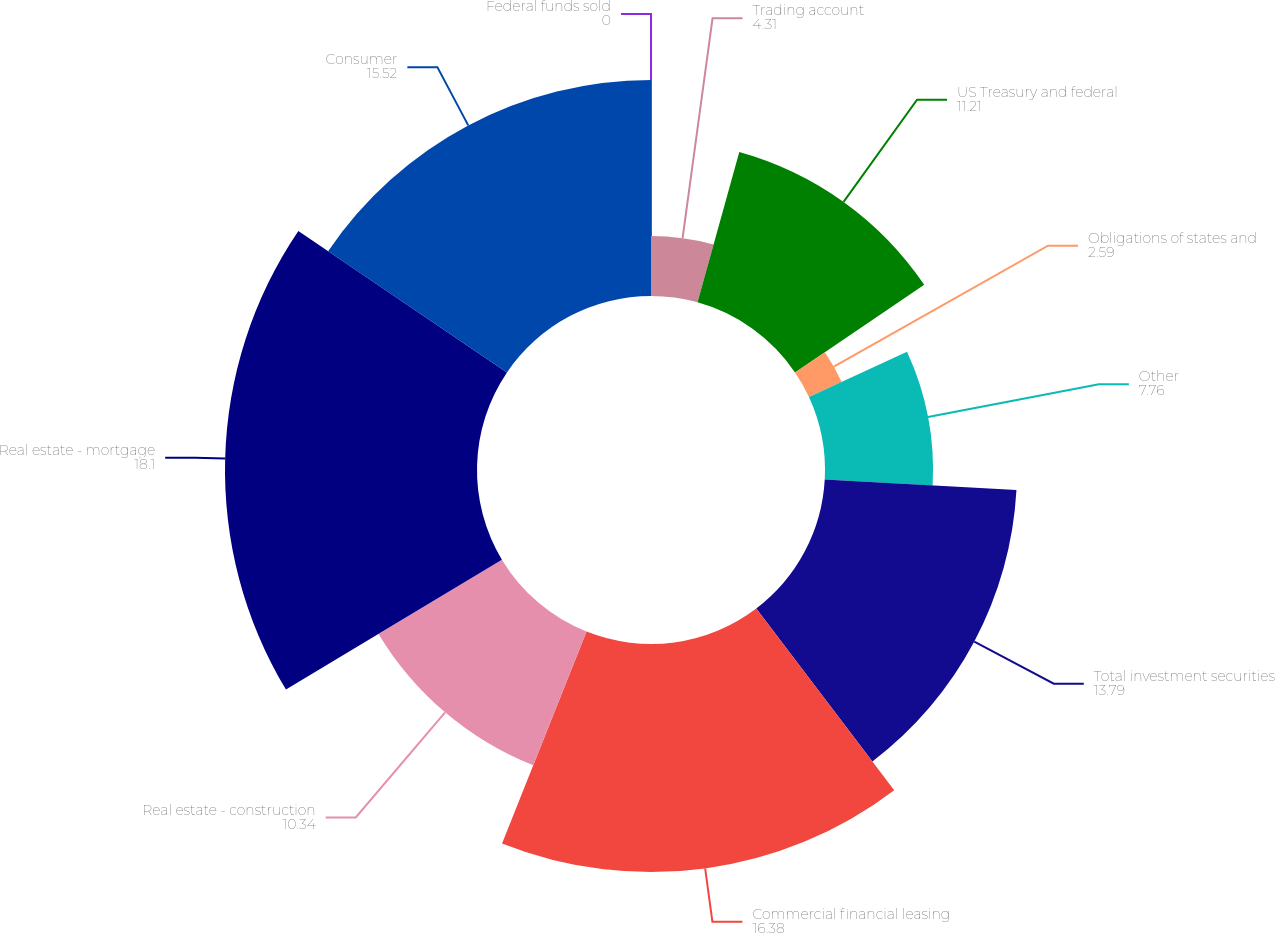Convert chart to OTSL. <chart><loc_0><loc_0><loc_500><loc_500><pie_chart><fcel>Federal funds sold<fcel>Trading account<fcel>US Treasury and federal<fcel>Obligations of states and<fcel>Other<fcel>Total investment securities<fcel>Commercial financial leasing<fcel>Real estate - construction<fcel>Real estate - mortgage<fcel>Consumer<nl><fcel>0.0%<fcel>4.31%<fcel>11.21%<fcel>2.59%<fcel>7.76%<fcel>13.79%<fcel>16.38%<fcel>10.34%<fcel>18.1%<fcel>15.52%<nl></chart> 